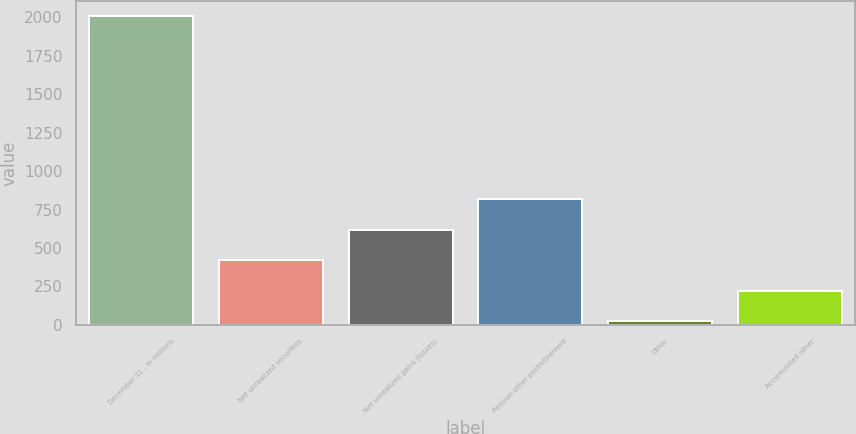<chart> <loc_0><loc_0><loc_500><loc_500><bar_chart><fcel>December 31 - in millions<fcel>Net unrealized securities<fcel>Net unrealized gains (losses)<fcel>Pension other postretirement<fcel>Other<fcel>Accumulated other<nl><fcel>2007<fcel>419<fcel>617.5<fcel>816<fcel>22<fcel>220.5<nl></chart> 